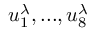Convert formula to latex. <formula><loc_0><loc_0><loc_500><loc_500>u _ { 1 } ^ { \lambda } , \dots , u _ { 8 } ^ { \lambda }</formula> 